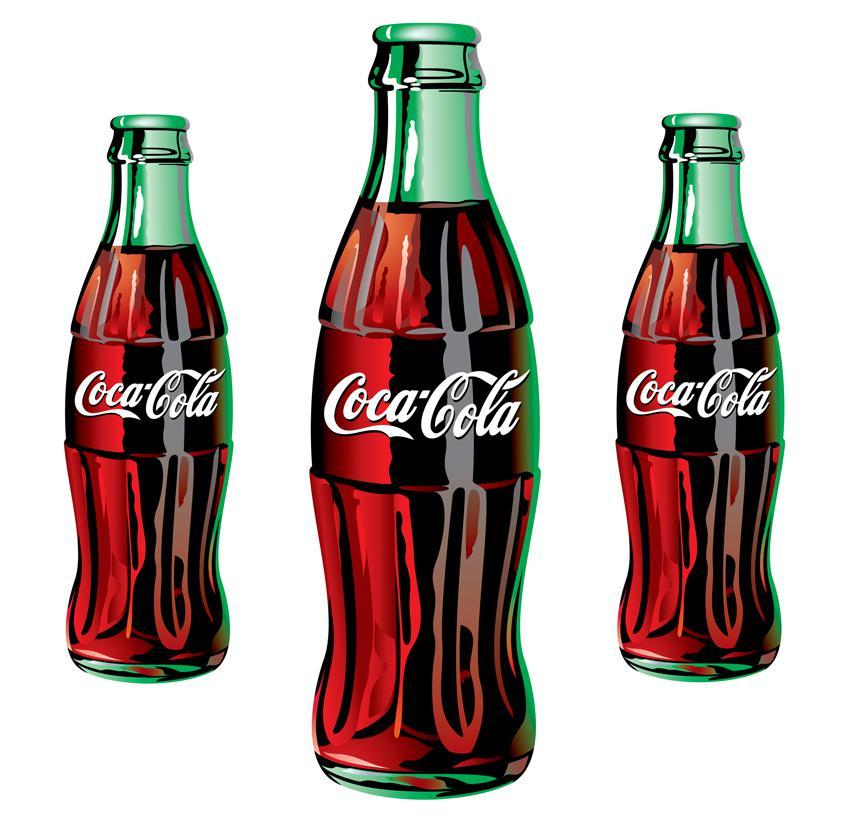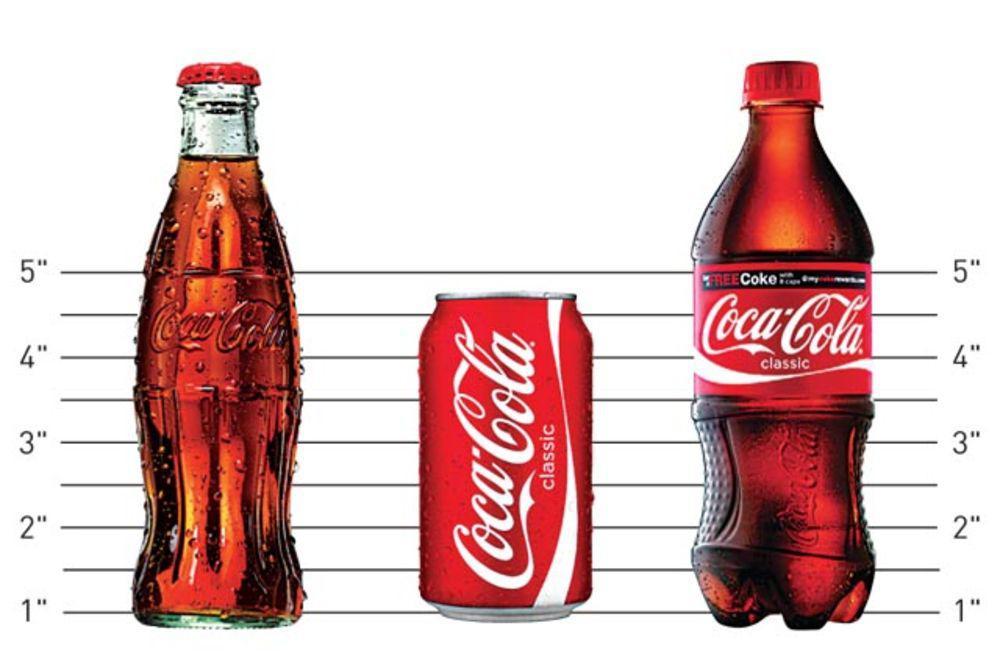The first image is the image on the left, the second image is the image on the right. Considering the images on both sides, is "Only plastic, filled soda bottles with lids and labels are shown, and the left image features at least one bottle with a semi-hourglass shape, while the right image shows three bottles with different labels." valid? Answer yes or no. No. The first image is the image on the left, the second image is the image on the right. For the images shown, is this caption "In the right image, there is a green colored plastic soda bottle" true? Answer yes or no. No. 